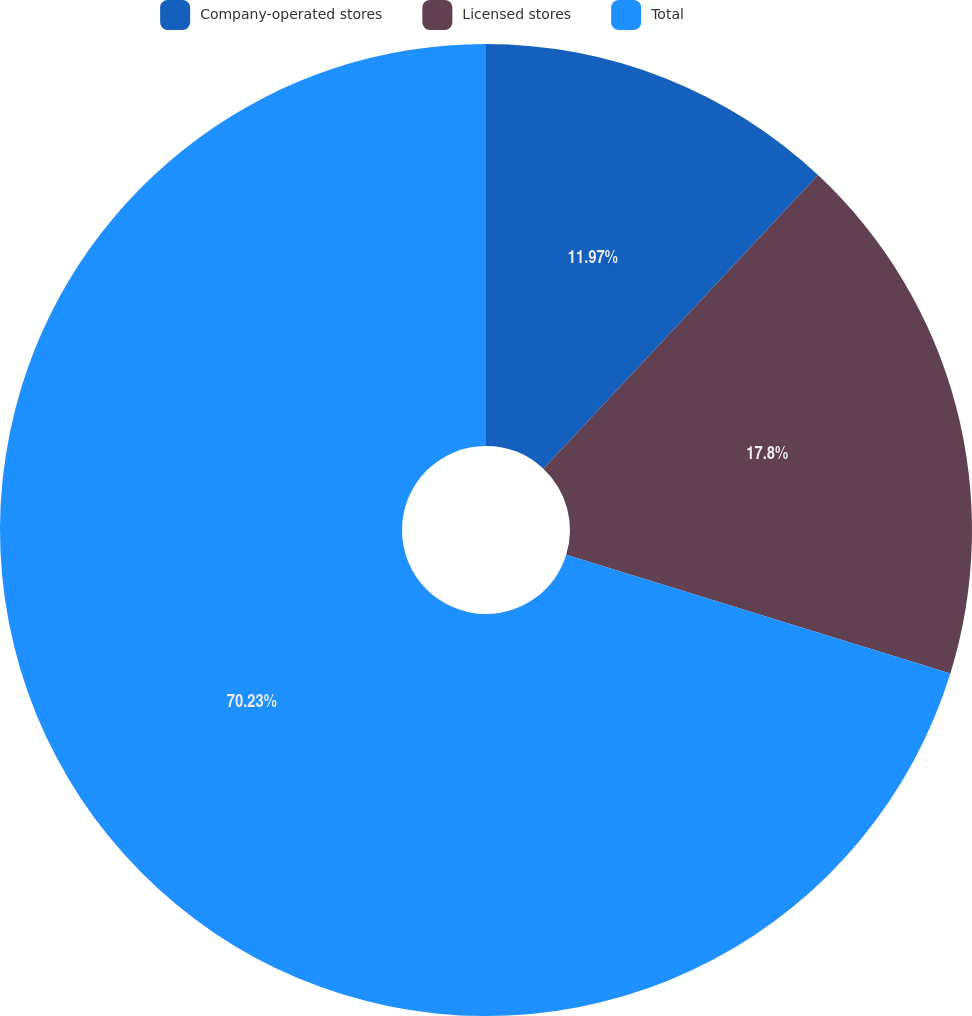<chart> <loc_0><loc_0><loc_500><loc_500><pie_chart><fcel>Company-operated stores<fcel>Licensed stores<fcel>Total<nl><fcel>11.97%<fcel>17.8%<fcel>70.23%<nl></chart> 